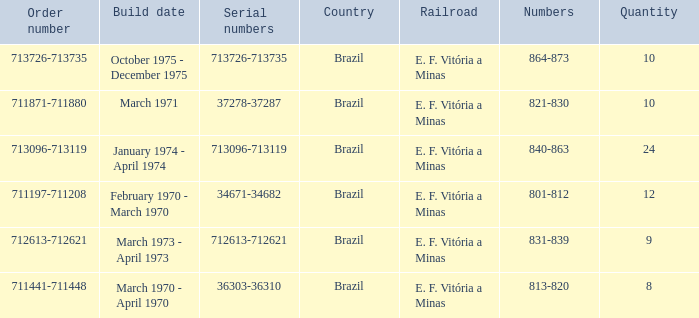What are the numbers for the order number 713096-713119? 840-863. Would you mind parsing the complete table? {'header': ['Order number', 'Build date', 'Serial numbers', 'Country', 'Railroad', 'Numbers', 'Quantity'], 'rows': [['713726-713735', 'October 1975 - December 1975', '713726-713735', 'Brazil', 'E. F. Vitória a Minas', '864-873', '10'], ['711871-711880', 'March 1971', '37278-37287', 'Brazil', 'E. F. Vitória a Minas', '821-830', '10'], ['713096-713119', 'January 1974 - April 1974', '713096-713119', 'Brazil', 'E. F. Vitória a Minas', '840-863', '24'], ['711197-711208', 'February 1970 - March 1970', '34671-34682', 'Brazil', 'E. F. Vitória a Minas', '801-812', '12'], ['712613-712621', 'March 1973 - April 1973', '712613-712621', 'Brazil', 'E. F. Vitória a Minas', '831-839', '9'], ['711441-711448', 'March 1970 - April 1970', '36303-36310', 'Brazil', 'E. F. Vitória a Minas', '813-820', '8']]} 